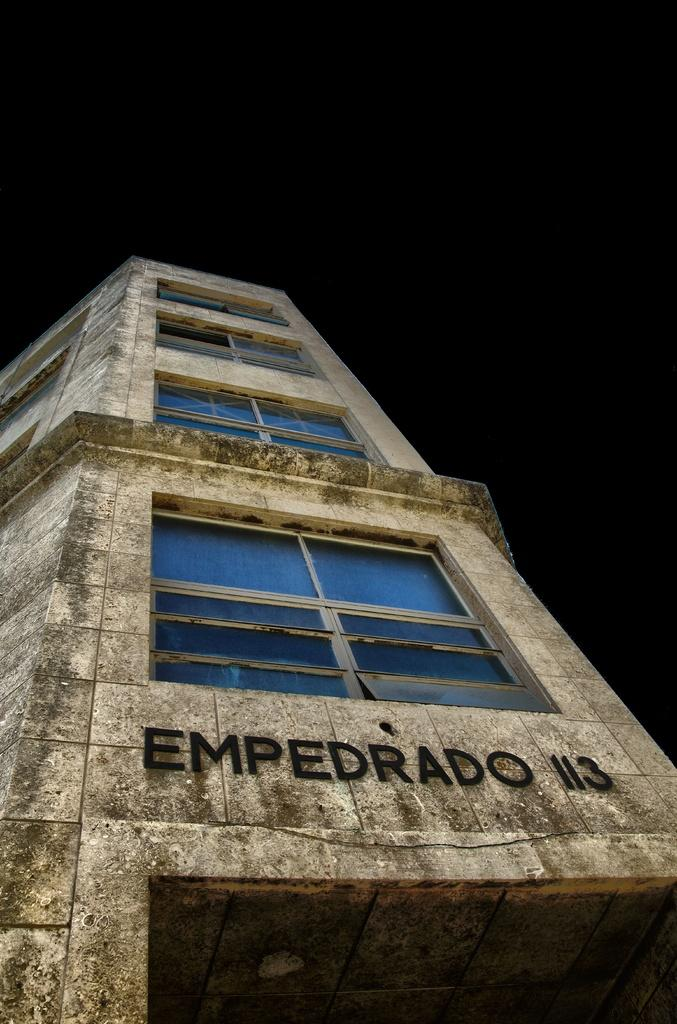What type of structure is present in the image? There is a building in the image. Are there any words or letters visible in the image? Yes, there is text visible in the image. What can be observed about the background of the image? The background of the image is dark. What type of silver object can be seen flying in the image? There is no silver object flying in the image; the image only features a building and text with a dark background. 